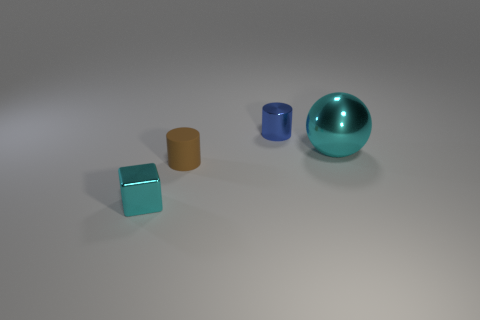There is a block that is the same color as the metal sphere; what material is it?
Make the answer very short. Metal. The metal thing that is both in front of the metal cylinder and to the left of the metallic ball is what color?
Your answer should be compact. Cyan. What is the shape of the metallic object left of the blue metallic thing?
Ensure brevity in your answer.  Cube. There is a cyan thing that is behind the cyan thing that is on the left side of the cyan object on the right side of the blue cylinder; what is its size?
Make the answer very short. Large. How many small metallic cylinders are on the left side of the small thing that is behind the large object?
Your response must be concise. 0. What is the size of the metallic object that is on the left side of the big metal sphere and behind the small cyan block?
Provide a short and direct response. Small. How many metal objects are small brown spheres or brown cylinders?
Offer a very short reply. 0. What material is the brown cylinder?
Your response must be concise. Rubber. What is the cyan thing that is right of the tiny metal thing to the left of the small metallic thing that is on the right side of the cyan block made of?
Provide a succinct answer. Metal. What is the shape of the cyan object that is the same size as the shiny cylinder?
Offer a terse response. Cube. 